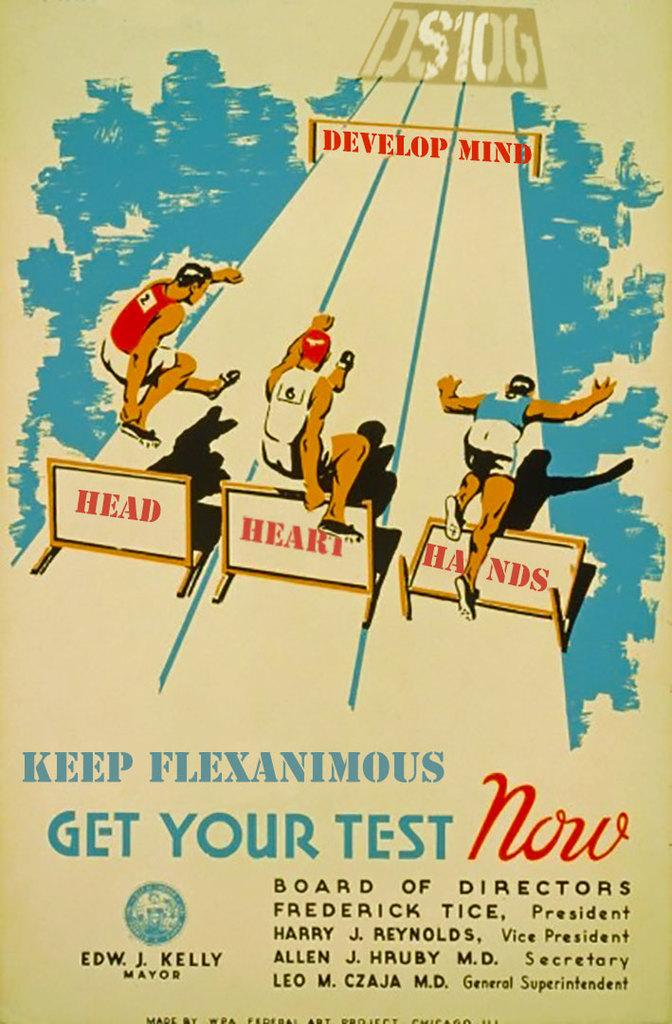<image>
Provide a brief description of the given image. poster showing hurdlers jumping over signs reading head, heart, and hands going toward develop mind finish line 